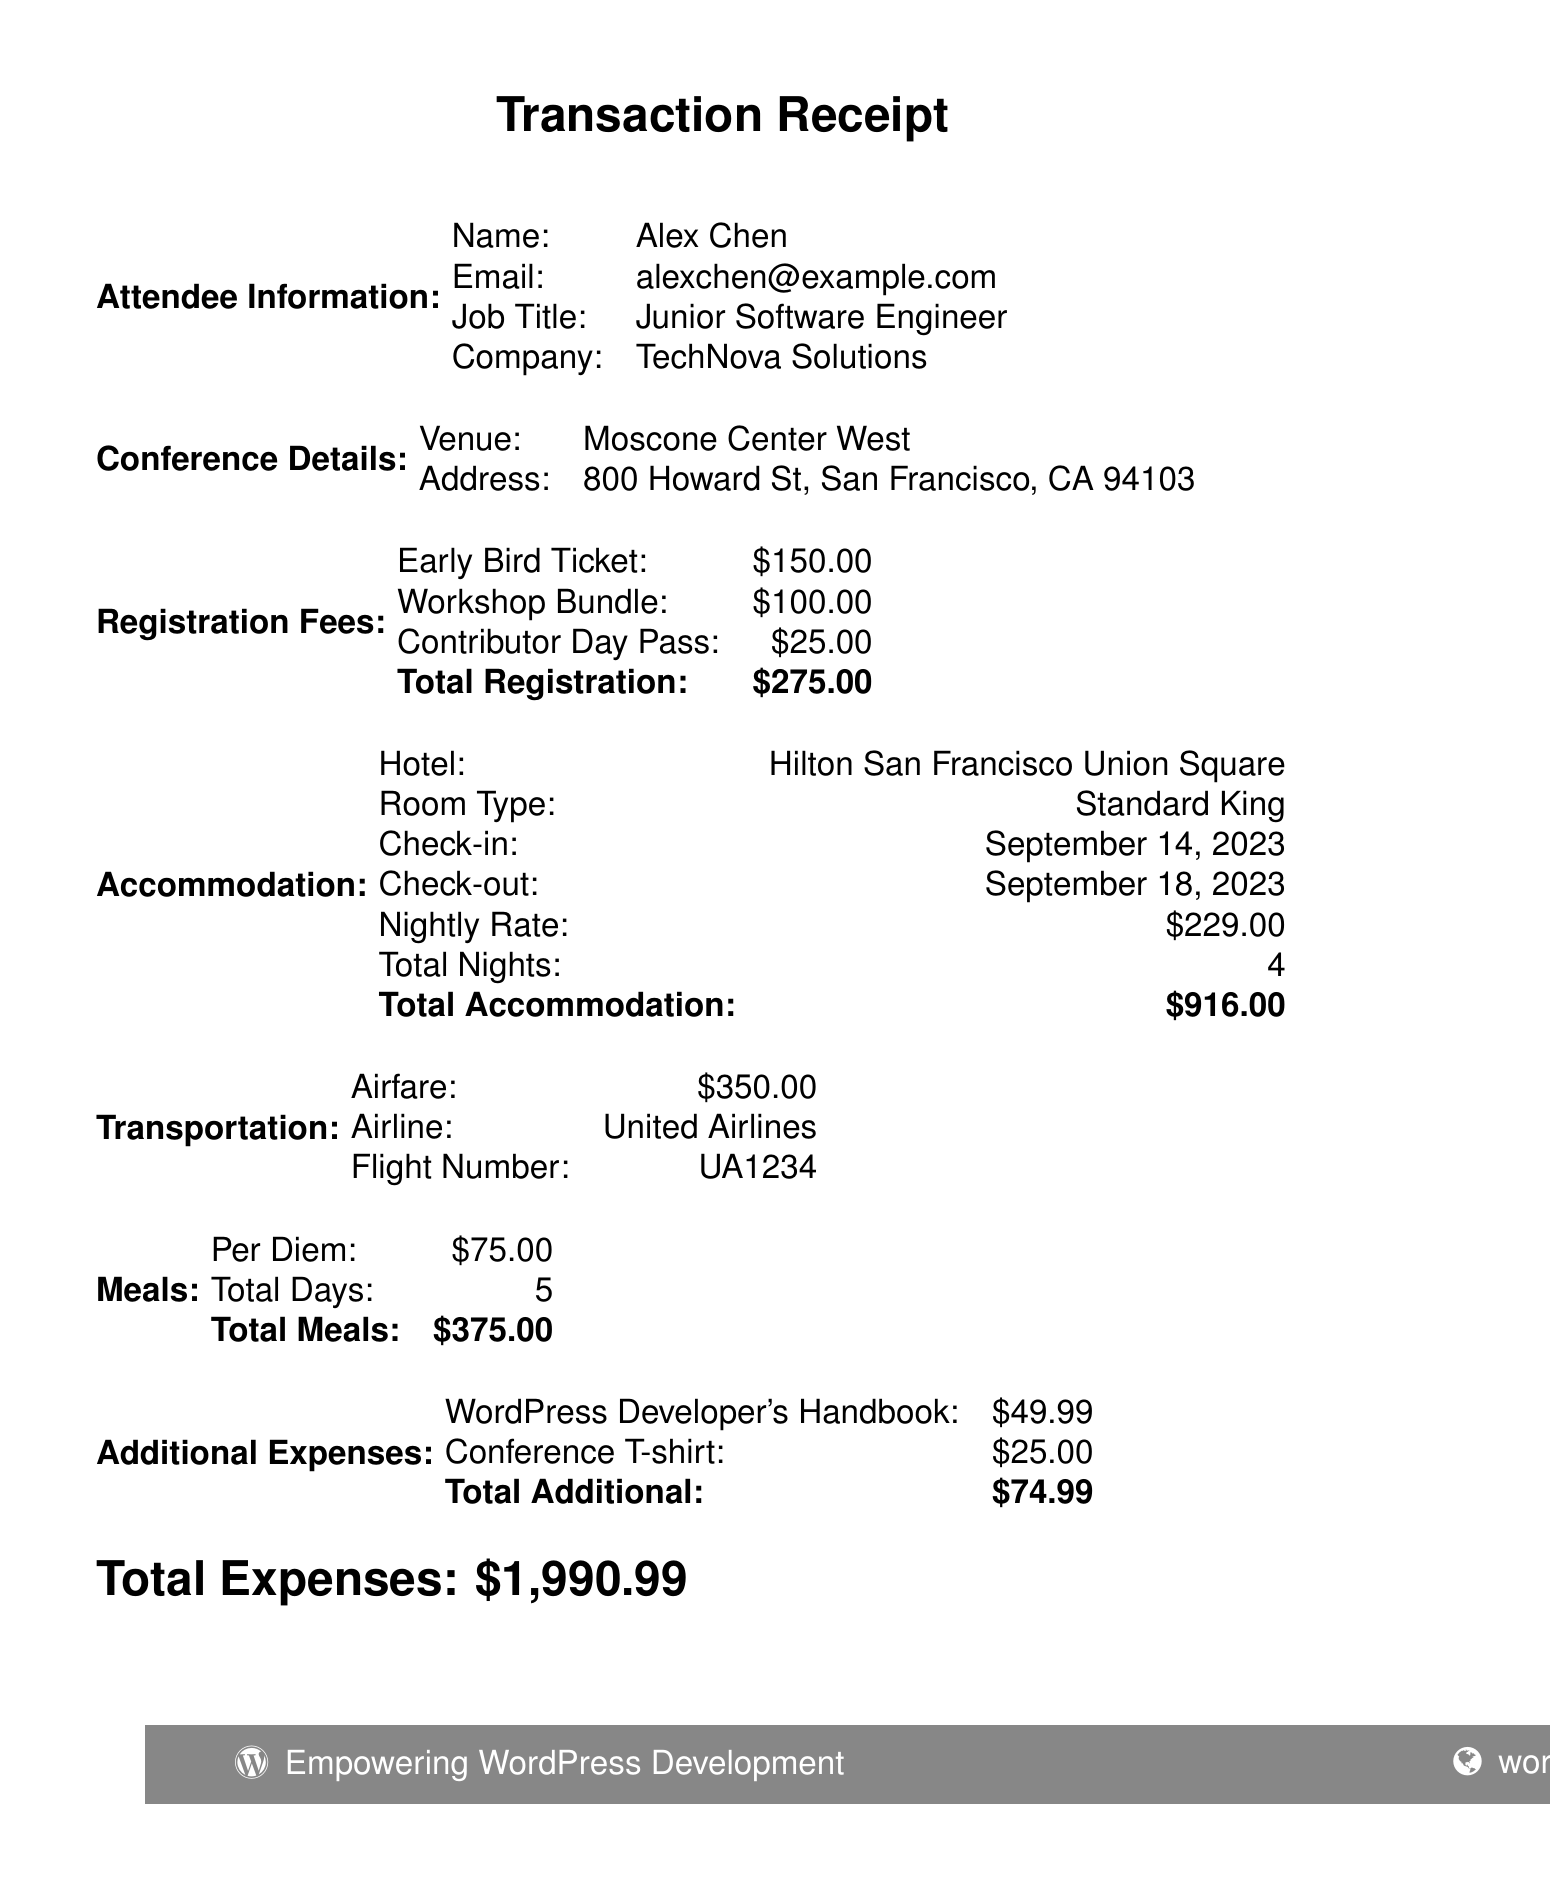What is the name of the conference? The name of the conference is stated in the document's title section.
Answer: WordCamp San Francisco 2023 What is the total registration fee? The total registration fee is calculated from the individual registration fees listed in the document.
Answer: $275.00 Who is the instructor for the workshop "Gutenberg Block Development"? The instructor's name for this workshop is provided in the workshops section of the document.
Answer: Zac Gordon What is the nightly rate for accommodation? The nightly rate for accommodation is mentioned specifically under the accommodation section of the document.
Answer: $229.00 How many nights will Alex stay at the hotel? The total nights Alex will stay is detailed in the accommodation section.
Answer: 4 What are the dates for the Welcome Reception networking event? The dates for the Welcome Reception are listed under the networking events section.
Answer: September 15, 2023 What is the total cost of additional expenses? The total cost is the sum of all additional expenses listed in the document.
Answer: $74.99 Which airline is Alex flying with? The airline name is specified in the transportation section of the document.
Answer: United Airlines What are the check-in and check-out dates for the hotel? These dates are listed under the accommodation section and provide the stay duration.
Answer: September 14, 2023 and September 18, 2023 